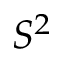Convert formula to latex. <formula><loc_0><loc_0><loc_500><loc_500>S ^ { 2 }</formula> 